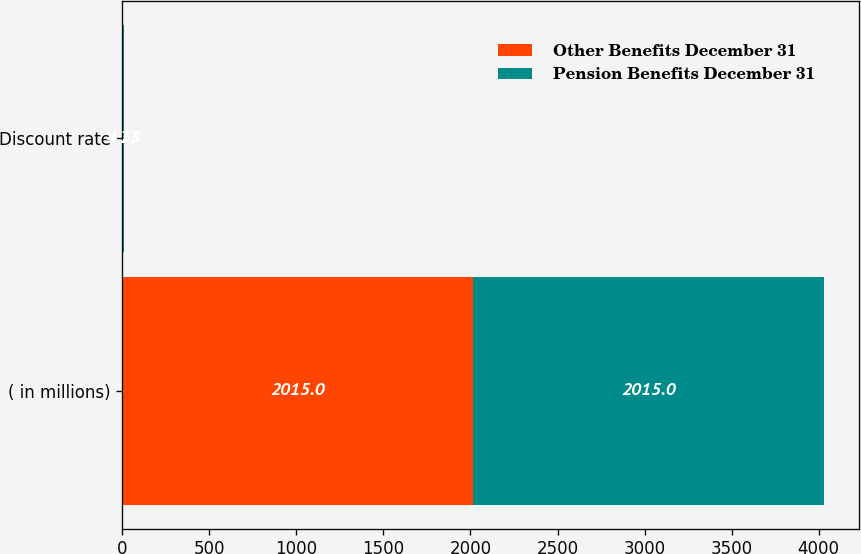Convert chart to OTSL. <chart><loc_0><loc_0><loc_500><loc_500><stacked_bar_chart><ecel><fcel>( in millions)<fcel>Discount rate<nl><fcel>Other Benefits December 31<fcel>2015<fcel>4.73<nl><fcel>Pension Benefits December 31<fcel>2015<fcel>4.58<nl></chart> 